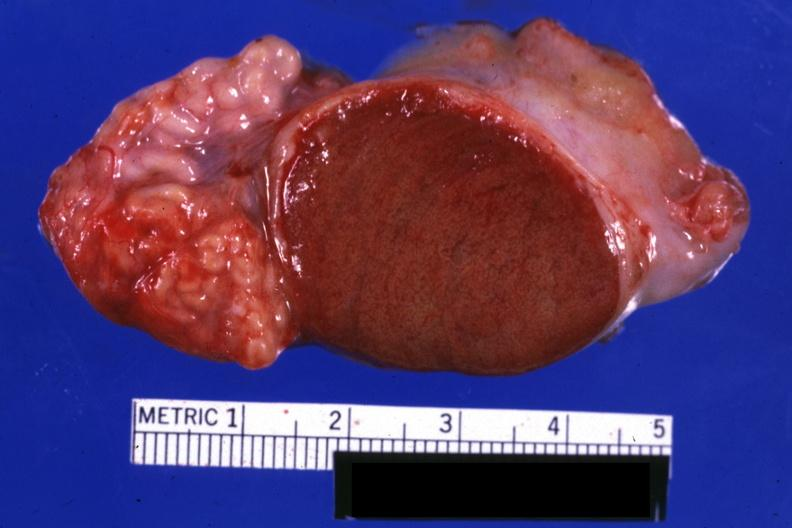how is excellent close-up view sliced open testicle?
Answer the question using a single word or phrase. Intact epididymis 